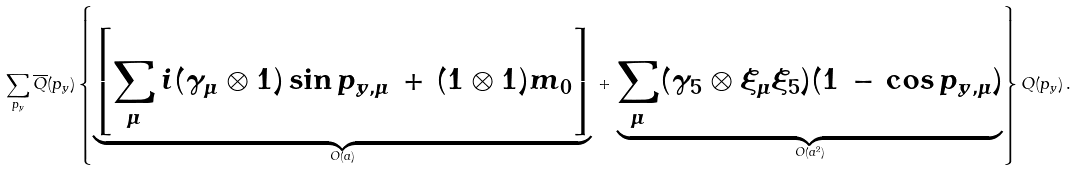<formula> <loc_0><loc_0><loc_500><loc_500>\sum _ { p _ { y } } \overline { Q } ( p _ { y } ) \left \{ \underbrace { \left [ \sum _ { \mu } i ( \gamma _ { \mu } \otimes { 1 } ) \sin p _ { y , \mu } \, + \, ( { 1 } \otimes { 1 } ) m _ { 0 } \right ] } _ { O ( a ) } \, + \, \underbrace { \sum _ { \mu } ( \gamma _ { 5 } \otimes \xi _ { \mu } \xi _ { 5 } ) ( 1 \, - \, \cos p _ { y , \mu } ) } _ { O ( a ^ { 2 } ) } \right \} Q ( p _ { y } ) \, .</formula> 